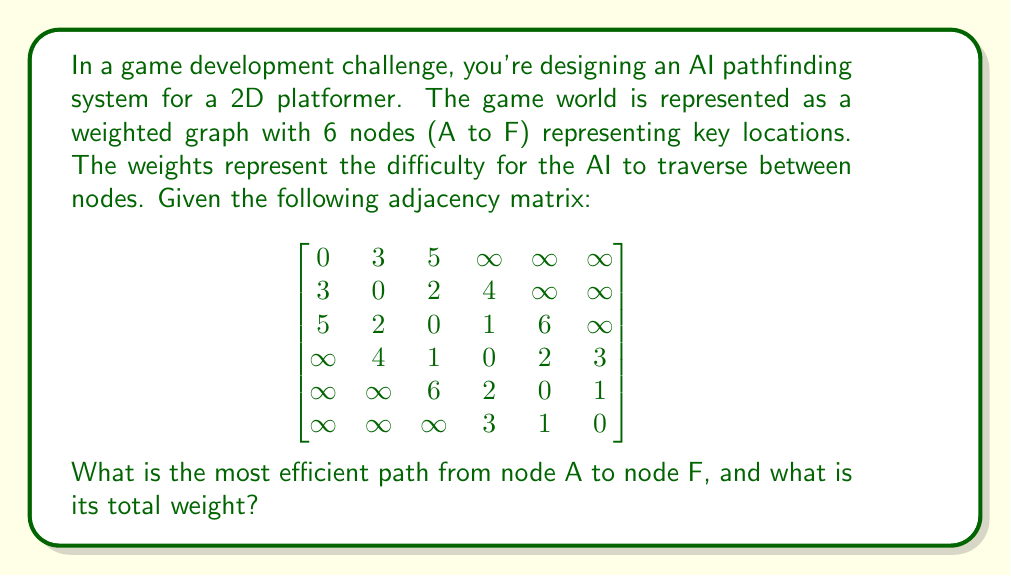What is the answer to this math problem? To solve this problem, we'll use Dijkstra's algorithm to find the shortest path from node A to all other nodes in the graph. Here's the step-by-step process:

1) Initialize:
   - Distance to A = 0
   - Distance to all other nodes = $\infty$
   - Set of unvisited nodes = {A, B, C, D, E, F}

2) Start from node A:
   - Update distances: A->B = 3, A->C = 5
   - Mark A as visited

3) Choose the node with the smallest distance (B):
   - Update distances: B->C = min(5, 3+2) = 5, B->D = 3+4 = 7
   - Mark B as visited

4) Choose the node with the smallest distance (C):
   - Update distances: C->D = min(7, 5+1) = 6, C->E = 5+6 = 11
   - Mark C as visited

5) Choose the node with the smallest distance (D):
   - Update distances: D->E = min(11, 6+2) = 8, D->F = 6+3 = 9
   - Mark D as visited

6) Choose the node with the smallest distance (E):
   - Update distances: E->F = min(9, 8+1) = 8
   - Mark E as visited

7) Node F is reached with a total distance of 8

The most efficient path is A -> B -> C -> D -> E -> F with a total weight of 8.
Answer: A -> B -> C -> D -> E -> F, weight 8 